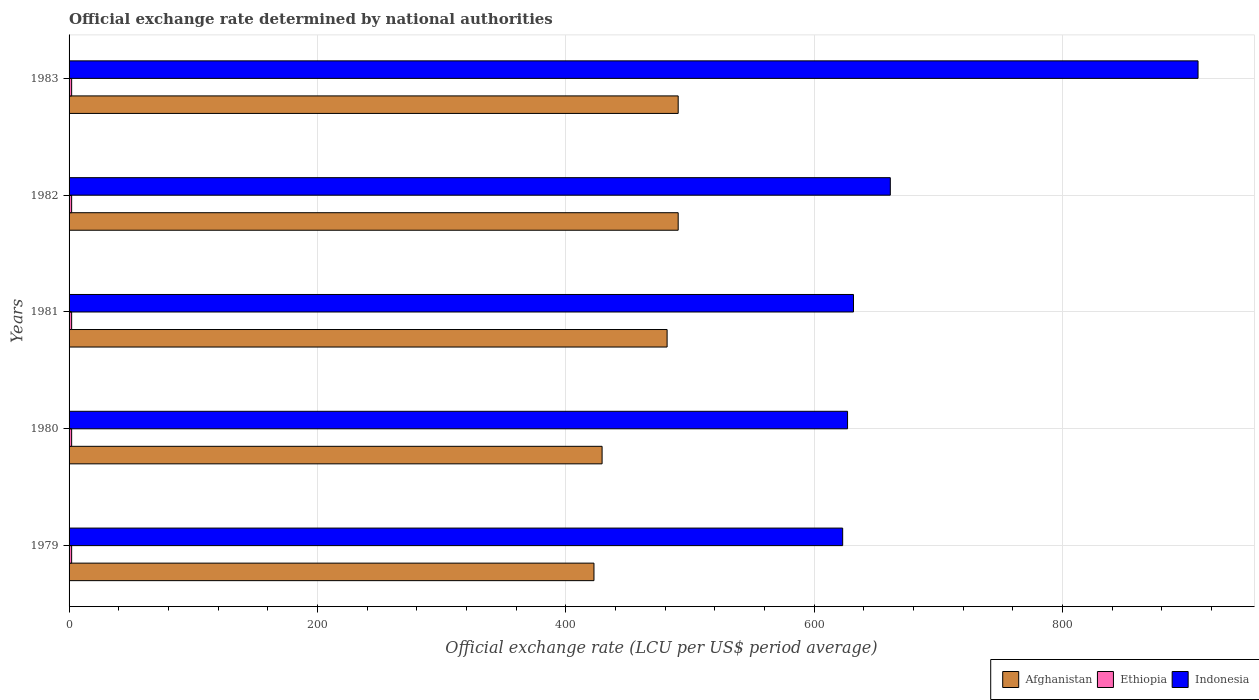How many groups of bars are there?
Ensure brevity in your answer.  5. Are the number of bars per tick equal to the number of legend labels?
Provide a short and direct response. Yes. Are the number of bars on each tick of the Y-axis equal?
Give a very brief answer. Yes. What is the label of the 1st group of bars from the top?
Make the answer very short. 1983. What is the official exchange rate in Afghanistan in 1981?
Give a very brief answer. 481.65. Across all years, what is the maximum official exchange rate in Ethiopia?
Make the answer very short. 2.07. Across all years, what is the minimum official exchange rate in Ethiopia?
Give a very brief answer. 2.07. In which year was the official exchange rate in Afghanistan minimum?
Your answer should be very brief. 1979. What is the total official exchange rate in Ethiopia in the graph?
Ensure brevity in your answer.  10.35. What is the difference between the official exchange rate in Indonesia in 1980 and that in 1982?
Keep it short and to the point. -34.43. What is the difference between the official exchange rate in Afghanistan in 1980 and the official exchange rate in Indonesia in 1979?
Make the answer very short. -193.77. What is the average official exchange rate in Ethiopia per year?
Keep it short and to the point. 2.07. In the year 1981, what is the difference between the official exchange rate in Ethiopia and official exchange rate in Afghanistan?
Keep it short and to the point. -479.58. What is the ratio of the official exchange rate in Afghanistan in 1980 to that in 1981?
Give a very brief answer. 0.89. Is the difference between the official exchange rate in Ethiopia in 1979 and 1981 greater than the difference between the official exchange rate in Afghanistan in 1979 and 1981?
Your answer should be very brief. Yes. What does the 3rd bar from the top in 1979 represents?
Your answer should be very brief. Afghanistan. Is it the case that in every year, the sum of the official exchange rate in Ethiopia and official exchange rate in Afghanistan is greater than the official exchange rate in Indonesia?
Your response must be concise. No. What is the difference between two consecutive major ticks on the X-axis?
Provide a succinct answer. 200. Does the graph contain any zero values?
Your answer should be compact. No. How are the legend labels stacked?
Offer a very short reply. Horizontal. What is the title of the graph?
Offer a terse response. Official exchange rate determined by national authorities. What is the label or title of the X-axis?
Your response must be concise. Official exchange rate (LCU per US$ period average). What is the label or title of the Y-axis?
Give a very brief answer. Years. What is the Official exchange rate (LCU per US$ period average) of Afghanistan in 1979?
Offer a very short reply. 422.75. What is the Official exchange rate (LCU per US$ period average) of Ethiopia in 1979?
Your answer should be very brief. 2.07. What is the Official exchange rate (LCU per US$ period average) of Indonesia in 1979?
Give a very brief answer. 623.06. What is the Official exchange rate (LCU per US$ period average) of Afghanistan in 1980?
Your answer should be very brief. 429.29. What is the Official exchange rate (LCU per US$ period average) in Ethiopia in 1980?
Offer a very short reply. 2.07. What is the Official exchange rate (LCU per US$ period average) of Indonesia in 1980?
Offer a very short reply. 626.99. What is the Official exchange rate (LCU per US$ period average) of Afghanistan in 1981?
Offer a terse response. 481.65. What is the Official exchange rate (LCU per US$ period average) of Ethiopia in 1981?
Ensure brevity in your answer.  2.07. What is the Official exchange rate (LCU per US$ period average) of Indonesia in 1981?
Ensure brevity in your answer.  631.76. What is the Official exchange rate (LCU per US$ period average) in Afghanistan in 1982?
Provide a succinct answer. 490.58. What is the Official exchange rate (LCU per US$ period average) of Ethiopia in 1982?
Ensure brevity in your answer.  2.07. What is the Official exchange rate (LCU per US$ period average) in Indonesia in 1982?
Offer a very short reply. 661.42. What is the Official exchange rate (LCU per US$ period average) in Afghanistan in 1983?
Your response must be concise. 490.58. What is the Official exchange rate (LCU per US$ period average) of Ethiopia in 1983?
Your answer should be compact. 2.07. What is the Official exchange rate (LCU per US$ period average) in Indonesia in 1983?
Provide a succinct answer. 909.26. Across all years, what is the maximum Official exchange rate (LCU per US$ period average) of Afghanistan?
Provide a short and direct response. 490.58. Across all years, what is the maximum Official exchange rate (LCU per US$ period average) of Ethiopia?
Your answer should be compact. 2.07. Across all years, what is the maximum Official exchange rate (LCU per US$ period average) in Indonesia?
Your answer should be very brief. 909.26. Across all years, what is the minimum Official exchange rate (LCU per US$ period average) of Afghanistan?
Keep it short and to the point. 422.75. Across all years, what is the minimum Official exchange rate (LCU per US$ period average) of Ethiopia?
Offer a terse response. 2.07. Across all years, what is the minimum Official exchange rate (LCU per US$ period average) of Indonesia?
Provide a short and direct response. 623.06. What is the total Official exchange rate (LCU per US$ period average) of Afghanistan in the graph?
Make the answer very short. 2314.85. What is the total Official exchange rate (LCU per US$ period average) of Ethiopia in the graph?
Provide a short and direct response. 10.35. What is the total Official exchange rate (LCU per US$ period average) of Indonesia in the graph?
Make the answer very short. 3452.49. What is the difference between the Official exchange rate (LCU per US$ period average) in Afghanistan in 1979 and that in 1980?
Offer a very short reply. -6.54. What is the difference between the Official exchange rate (LCU per US$ period average) in Indonesia in 1979 and that in 1980?
Provide a short and direct response. -3.94. What is the difference between the Official exchange rate (LCU per US$ period average) of Afghanistan in 1979 and that in 1981?
Offer a very short reply. -58.9. What is the difference between the Official exchange rate (LCU per US$ period average) in Indonesia in 1979 and that in 1981?
Provide a succinct answer. -8.7. What is the difference between the Official exchange rate (LCU per US$ period average) in Afghanistan in 1979 and that in 1982?
Your answer should be compact. -67.83. What is the difference between the Official exchange rate (LCU per US$ period average) of Ethiopia in 1979 and that in 1982?
Ensure brevity in your answer.  0. What is the difference between the Official exchange rate (LCU per US$ period average) of Indonesia in 1979 and that in 1982?
Provide a short and direct response. -38.37. What is the difference between the Official exchange rate (LCU per US$ period average) of Afghanistan in 1979 and that in 1983?
Ensure brevity in your answer.  -67.83. What is the difference between the Official exchange rate (LCU per US$ period average) in Indonesia in 1979 and that in 1983?
Offer a very short reply. -286.21. What is the difference between the Official exchange rate (LCU per US$ period average) of Afghanistan in 1980 and that in 1981?
Your answer should be very brief. -52.36. What is the difference between the Official exchange rate (LCU per US$ period average) of Ethiopia in 1980 and that in 1981?
Keep it short and to the point. 0. What is the difference between the Official exchange rate (LCU per US$ period average) of Indonesia in 1980 and that in 1981?
Your response must be concise. -4.76. What is the difference between the Official exchange rate (LCU per US$ period average) in Afghanistan in 1980 and that in 1982?
Offer a terse response. -61.29. What is the difference between the Official exchange rate (LCU per US$ period average) of Indonesia in 1980 and that in 1982?
Give a very brief answer. -34.43. What is the difference between the Official exchange rate (LCU per US$ period average) in Afghanistan in 1980 and that in 1983?
Make the answer very short. -61.29. What is the difference between the Official exchange rate (LCU per US$ period average) of Indonesia in 1980 and that in 1983?
Provide a short and direct response. -282.27. What is the difference between the Official exchange rate (LCU per US$ period average) of Afghanistan in 1981 and that in 1982?
Give a very brief answer. -8.93. What is the difference between the Official exchange rate (LCU per US$ period average) in Indonesia in 1981 and that in 1982?
Make the answer very short. -29.66. What is the difference between the Official exchange rate (LCU per US$ period average) in Afghanistan in 1981 and that in 1983?
Offer a terse response. -8.93. What is the difference between the Official exchange rate (LCU per US$ period average) in Ethiopia in 1981 and that in 1983?
Provide a short and direct response. 0. What is the difference between the Official exchange rate (LCU per US$ period average) of Indonesia in 1981 and that in 1983?
Provide a short and direct response. -277.51. What is the difference between the Official exchange rate (LCU per US$ period average) of Ethiopia in 1982 and that in 1983?
Keep it short and to the point. 0. What is the difference between the Official exchange rate (LCU per US$ period average) in Indonesia in 1982 and that in 1983?
Your answer should be very brief. -247.84. What is the difference between the Official exchange rate (LCU per US$ period average) of Afghanistan in 1979 and the Official exchange rate (LCU per US$ period average) of Ethiopia in 1980?
Keep it short and to the point. 420.68. What is the difference between the Official exchange rate (LCU per US$ period average) in Afghanistan in 1979 and the Official exchange rate (LCU per US$ period average) in Indonesia in 1980?
Your response must be concise. -204.24. What is the difference between the Official exchange rate (LCU per US$ period average) in Ethiopia in 1979 and the Official exchange rate (LCU per US$ period average) in Indonesia in 1980?
Give a very brief answer. -624.92. What is the difference between the Official exchange rate (LCU per US$ period average) of Afghanistan in 1979 and the Official exchange rate (LCU per US$ period average) of Ethiopia in 1981?
Provide a succinct answer. 420.68. What is the difference between the Official exchange rate (LCU per US$ period average) in Afghanistan in 1979 and the Official exchange rate (LCU per US$ period average) in Indonesia in 1981?
Your response must be concise. -209. What is the difference between the Official exchange rate (LCU per US$ period average) in Ethiopia in 1979 and the Official exchange rate (LCU per US$ period average) in Indonesia in 1981?
Your response must be concise. -629.69. What is the difference between the Official exchange rate (LCU per US$ period average) of Afghanistan in 1979 and the Official exchange rate (LCU per US$ period average) of Ethiopia in 1982?
Your answer should be very brief. 420.68. What is the difference between the Official exchange rate (LCU per US$ period average) in Afghanistan in 1979 and the Official exchange rate (LCU per US$ period average) in Indonesia in 1982?
Provide a succinct answer. -238.67. What is the difference between the Official exchange rate (LCU per US$ period average) of Ethiopia in 1979 and the Official exchange rate (LCU per US$ period average) of Indonesia in 1982?
Offer a terse response. -659.35. What is the difference between the Official exchange rate (LCU per US$ period average) in Afghanistan in 1979 and the Official exchange rate (LCU per US$ period average) in Ethiopia in 1983?
Keep it short and to the point. 420.68. What is the difference between the Official exchange rate (LCU per US$ period average) of Afghanistan in 1979 and the Official exchange rate (LCU per US$ period average) of Indonesia in 1983?
Make the answer very short. -486.51. What is the difference between the Official exchange rate (LCU per US$ period average) of Ethiopia in 1979 and the Official exchange rate (LCU per US$ period average) of Indonesia in 1983?
Keep it short and to the point. -907.19. What is the difference between the Official exchange rate (LCU per US$ period average) of Afghanistan in 1980 and the Official exchange rate (LCU per US$ period average) of Ethiopia in 1981?
Keep it short and to the point. 427.22. What is the difference between the Official exchange rate (LCU per US$ period average) of Afghanistan in 1980 and the Official exchange rate (LCU per US$ period average) of Indonesia in 1981?
Provide a succinct answer. -202.47. What is the difference between the Official exchange rate (LCU per US$ period average) in Ethiopia in 1980 and the Official exchange rate (LCU per US$ period average) in Indonesia in 1981?
Provide a short and direct response. -629.69. What is the difference between the Official exchange rate (LCU per US$ period average) in Afghanistan in 1980 and the Official exchange rate (LCU per US$ period average) in Ethiopia in 1982?
Ensure brevity in your answer.  427.22. What is the difference between the Official exchange rate (LCU per US$ period average) in Afghanistan in 1980 and the Official exchange rate (LCU per US$ period average) in Indonesia in 1982?
Your response must be concise. -232.13. What is the difference between the Official exchange rate (LCU per US$ period average) in Ethiopia in 1980 and the Official exchange rate (LCU per US$ period average) in Indonesia in 1982?
Your response must be concise. -659.35. What is the difference between the Official exchange rate (LCU per US$ period average) in Afghanistan in 1980 and the Official exchange rate (LCU per US$ period average) in Ethiopia in 1983?
Offer a terse response. 427.22. What is the difference between the Official exchange rate (LCU per US$ period average) of Afghanistan in 1980 and the Official exchange rate (LCU per US$ period average) of Indonesia in 1983?
Make the answer very short. -479.98. What is the difference between the Official exchange rate (LCU per US$ period average) of Ethiopia in 1980 and the Official exchange rate (LCU per US$ period average) of Indonesia in 1983?
Provide a short and direct response. -907.19. What is the difference between the Official exchange rate (LCU per US$ period average) in Afghanistan in 1981 and the Official exchange rate (LCU per US$ period average) in Ethiopia in 1982?
Make the answer very short. 479.58. What is the difference between the Official exchange rate (LCU per US$ period average) in Afghanistan in 1981 and the Official exchange rate (LCU per US$ period average) in Indonesia in 1982?
Ensure brevity in your answer.  -179.77. What is the difference between the Official exchange rate (LCU per US$ period average) in Ethiopia in 1981 and the Official exchange rate (LCU per US$ period average) in Indonesia in 1982?
Provide a succinct answer. -659.35. What is the difference between the Official exchange rate (LCU per US$ period average) of Afghanistan in 1981 and the Official exchange rate (LCU per US$ period average) of Ethiopia in 1983?
Offer a terse response. 479.58. What is the difference between the Official exchange rate (LCU per US$ period average) of Afghanistan in 1981 and the Official exchange rate (LCU per US$ period average) of Indonesia in 1983?
Give a very brief answer. -427.61. What is the difference between the Official exchange rate (LCU per US$ period average) in Ethiopia in 1981 and the Official exchange rate (LCU per US$ period average) in Indonesia in 1983?
Provide a succinct answer. -907.19. What is the difference between the Official exchange rate (LCU per US$ period average) in Afghanistan in 1982 and the Official exchange rate (LCU per US$ period average) in Ethiopia in 1983?
Your response must be concise. 488.51. What is the difference between the Official exchange rate (LCU per US$ period average) of Afghanistan in 1982 and the Official exchange rate (LCU per US$ period average) of Indonesia in 1983?
Ensure brevity in your answer.  -418.69. What is the difference between the Official exchange rate (LCU per US$ period average) in Ethiopia in 1982 and the Official exchange rate (LCU per US$ period average) in Indonesia in 1983?
Provide a short and direct response. -907.19. What is the average Official exchange rate (LCU per US$ period average) in Afghanistan per year?
Your answer should be very brief. 462.97. What is the average Official exchange rate (LCU per US$ period average) of Ethiopia per year?
Provide a succinct answer. 2.07. What is the average Official exchange rate (LCU per US$ period average) in Indonesia per year?
Provide a short and direct response. 690.5. In the year 1979, what is the difference between the Official exchange rate (LCU per US$ period average) in Afghanistan and Official exchange rate (LCU per US$ period average) in Ethiopia?
Your answer should be very brief. 420.68. In the year 1979, what is the difference between the Official exchange rate (LCU per US$ period average) in Afghanistan and Official exchange rate (LCU per US$ period average) in Indonesia?
Offer a very short reply. -200.3. In the year 1979, what is the difference between the Official exchange rate (LCU per US$ period average) of Ethiopia and Official exchange rate (LCU per US$ period average) of Indonesia?
Offer a very short reply. -620.99. In the year 1980, what is the difference between the Official exchange rate (LCU per US$ period average) of Afghanistan and Official exchange rate (LCU per US$ period average) of Ethiopia?
Keep it short and to the point. 427.22. In the year 1980, what is the difference between the Official exchange rate (LCU per US$ period average) of Afghanistan and Official exchange rate (LCU per US$ period average) of Indonesia?
Provide a succinct answer. -197.7. In the year 1980, what is the difference between the Official exchange rate (LCU per US$ period average) of Ethiopia and Official exchange rate (LCU per US$ period average) of Indonesia?
Give a very brief answer. -624.92. In the year 1981, what is the difference between the Official exchange rate (LCU per US$ period average) of Afghanistan and Official exchange rate (LCU per US$ period average) of Ethiopia?
Provide a succinct answer. 479.58. In the year 1981, what is the difference between the Official exchange rate (LCU per US$ period average) in Afghanistan and Official exchange rate (LCU per US$ period average) in Indonesia?
Offer a terse response. -150.1. In the year 1981, what is the difference between the Official exchange rate (LCU per US$ period average) in Ethiopia and Official exchange rate (LCU per US$ period average) in Indonesia?
Offer a very short reply. -629.69. In the year 1982, what is the difference between the Official exchange rate (LCU per US$ period average) in Afghanistan and Official exchange rate (LCU per US$ period average) in Ethiopia?
Keep it short and to the point. 488.51. In the year 1982, what is the difference between the Official exchange rate (LCU per US$ period average) in Afghanistan and Official exchange rate (LCU per US$ period average) in Indonesia?
Give a very brief answer. -170.84. In the year 1982, what is the difference between the Official exchange rate (LCU per US$ period average) of Ethiopia and Official exchange rate (LCU per US$ period average) of Indonesia?
Your answer should be compact. -659.35. In the year 1983, what is the difference between the Official exchange rate (LCU per US$ period average) of Afghanistan and Official exchange rate (LCU per US$ period average) of Ethiopia?
Provide a short and direct response. 488.51. In the year 1983, what is the difference between the Official exchange rate (LCU per US$ period average) in Afghanistan and Official exchange rate (LCU per US$ period average) in Indonesia?
Your response must be concise. -418.69. In the year 1983, what is the difference between the Official exchange rate (LCU per US$ period average) of Ethiopia and Official exchange rate (LCU per US$ period average) of Indonesia?
Make the answer very short. -907.19. What is the ratio of the Official exchange rate (LCU per US$ period average) of Afghanistan in 1979 to that in 1980?
Provide a short and direct response. 0.98. What is the ratio of the Official exchange rate (LCU per US$ period average) of Ethiopia in 1979 to that in 1980?
Offer a terse response. 1. What is the ratio of the Official exchange rate (LCU per US$ period average) in Afghanistan in 1979 to that in 1981?
Make the answer very short. 0.88. What is the ratio of the Official exchange rate (LCU per US$ period average) of Ethiopia in 1979 to that in 1981?
Offer a very short reply. 1. What is the ratio of the Official exchange rate (LCU per US$ period average) in Indonesia in 1979 to that in 1981?
Keep it short and to the point. 0.99. What is the ratio of the Official exchange rate (LCU per US$ period average) of Afghanistan in 1979 to that in 1982?
Offer a terse response. 0.86. What is the ratio of the Official exchange rate (LCU per US$ period average) of Indonesia in 1979 to that in 1982?
Your answer should be compact. 0.94. What is the ratio of the Official exchange rate (LCU per US$ period average) in Afghanistan in 1979 to that in 1983?
Keep it short and to the point. 0.86. What is the ratio of the Official exchange rate (LCU per US$ period average) of Indonesia in 1979 to that in 1983?
Your answer should be compact. 0.69. What is the ratio of the Official exchange rate (LCU per US$ period average) of Afghanistan in 1980 to that in 1981?
Provide a succinct answer. 0.89. What is the ratio of the Official exchange rate (LCU per US$ period average) in Ethiopia in 1980 to that in 1981?
Keep it short and to the point. 1. What is the ratio of the Official exchange rate (LCU per US$ period average) in Afghanistan in 1980 to that in 1982?
Offer a terse response. 0.88. What is the ratio of the Official exchange rate (LCU per US$ period average) of Ethiopia in 1980 to that in 1982?
Keep it short and to the point. 1. What is the ratio of the Official exchange rate (LCU per US$ period average) in Indonesia in 1980 to that in 1982?
Offer a very short reply. 0.95. What is the ratio of the Official exchange rate (LCU per US$ period average) of Afghanistan in 1980 to that in 1983?
Ensure brevity in your answer.  0.88. What is the ratio of the Official exchange rate (LCU per US$ period average) in Indonesia in 1980 to that in 1983?
Your answer should be very brief. 0.69. What is the ratio of the Official exchange rate (LCU per US$ period average) of Afghanistan in 1981 to that in 1982?
Your answer should be compact. 0.98. What is the ratio of the Official exchange rate (LCU per US$ period average) in Indonesia in 1981 to that in 1982?
Your answer should be very brief. 0.96. What is the ratio of the Official exchange rate (LCU per US$ period average) of Afghanistan in 1981 to that in 1983?
Give a very brief answer. 0.98. What is the ratio of the Official exchange rate (LCU per US$ period average) of Ethiopia in 1981 to that in 1983?
Keep it short and to the point. 1. What is the ratio of the Official exchange rate (LCU per US$ period average) of Indonesia in 1981 to that in 1983?
Offer a very short reply. 0.69. What is the ratio of the Official exchange rate (LCU per US$ period average) in Ethiopia in 1982 to that in 1983?
Offer a terse response. 1. What is the ratio of the Official exchange rate (LCU per US$ period average) in Indonesia in 1982 to that in 1983?
Your answer should be very brief. 0.73. What is the difference between the highest and the second highest Official exchange rate (LCU per US$ period average) of Indonesia?
Your answer should be very brief. 247.84. What is the difference between the highest and the lowest Official exchange rate (LCU per US$ period average) in Afghanistan?
Ensure brevity in your answer.  67.83. What is the difference between the highest and the lowest Official exchange rate (LCU per US$ period average) in Indonesia?
Ensure brevity in your answer.  286.21. 